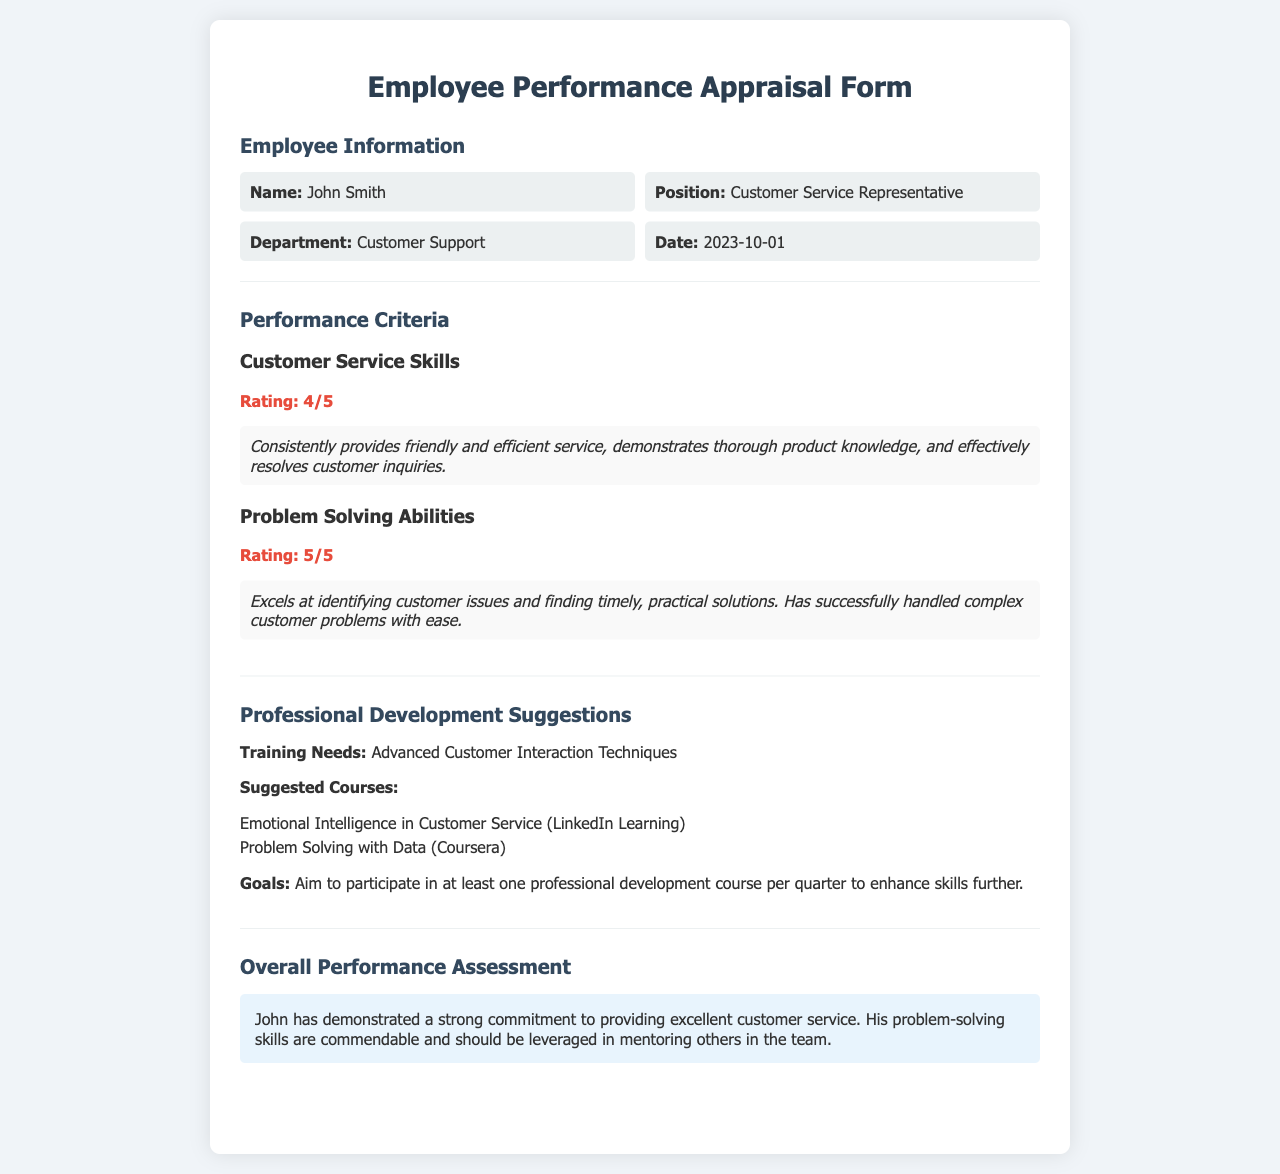what is the employee's name? The employee's name is listed in the document under Employee Information.
Answer: John Smith what is the employee's position? The employee's position is mentioned in the section dedicated to Employee Information.
Answer: Customer Service Representative what was the customer service skills rating? The rating for customer service skills is specified in the Performance Criteria section of the document.
Answer: 4/5 what is the rating for problem-solving abilities? This rating can be found in the Performance Criteria section specifically for Problem Solving Abilities.
Answer: 5/5 what is one suggested course for professional development? The suggested courses are listed in the Professional Development Suggestions section, where specific training resources are mentioned.
Answer: Emotional Intelligence in Customer Service how often should the employee aim to participate in professional development courses? This frequency is mentioned in the Professional Development Suggestions section.
Answer: Once per quarter what is the employee's overall performance assessment? The overall assessment is provided in the Overall Performance Assessment section summarizing the employee's performance.
Answer: Strong commitment to providing excellent customer service what advanced training is identified as a need? The training needs are outlined in the Professional Development Suggestions section of the document, where specific areas for improvement are indicated.
Answer: Advanced Customer Interaction Techniques who can benefit from the employee's problem-solving skills? This is inferred from the Overall Performance Assessment provided in the document, indicating who may benefit from the strengths of the employee.
Answer: Others in the team 